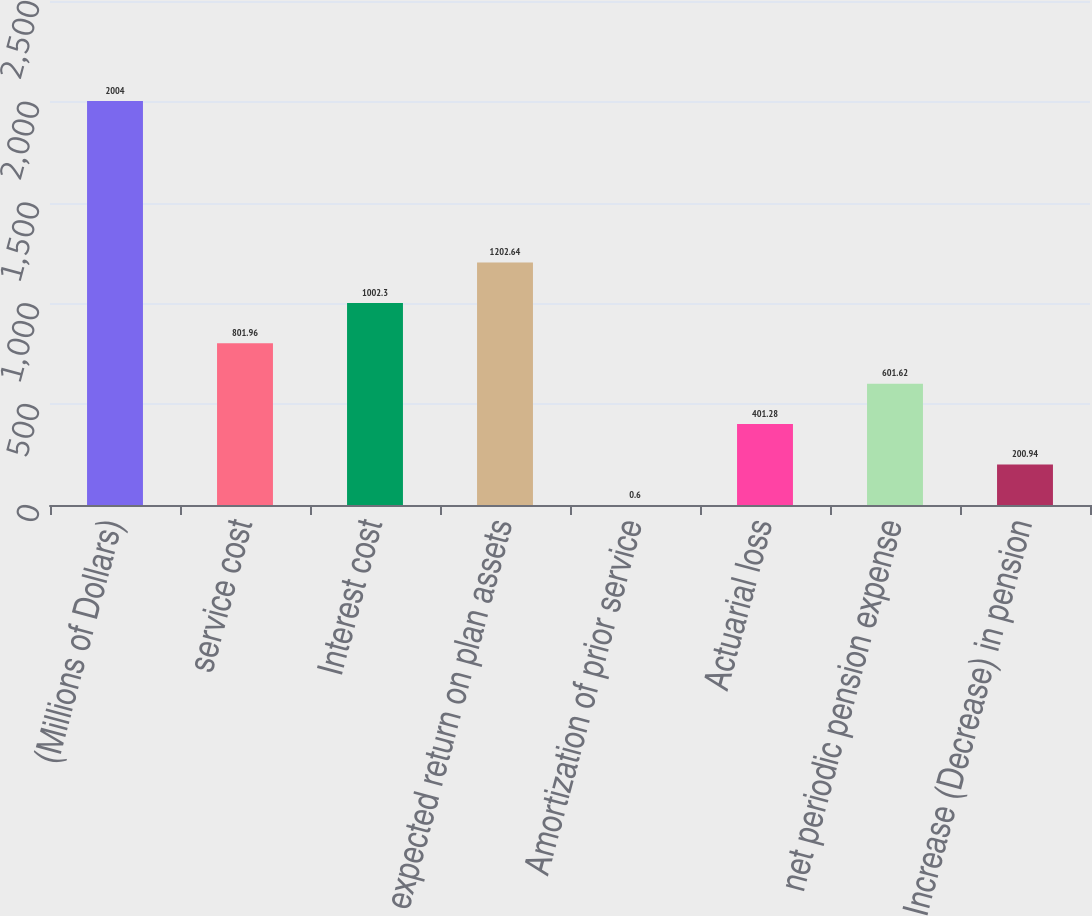Convert chart to OTSL. <chart><loc_0><loc_0><loc_500><loc_500><bar_chart><fcel>(Millions of Dollars)<fcel>service cost<fcel>Interest cost<fcel>expected return on plan assets<fcel>Amortization of prior service<fcel>Actuarial loss<fcel>net periodic pension expense<fcel>Increase (Decrease) in pension<nl><fcel>2004<fcel>801.96<fcel>1002.3<fcel>1202.64<fcel>0.6<fcel>401.28<fcel>601.62<fcel>200.94<nl></chart> 